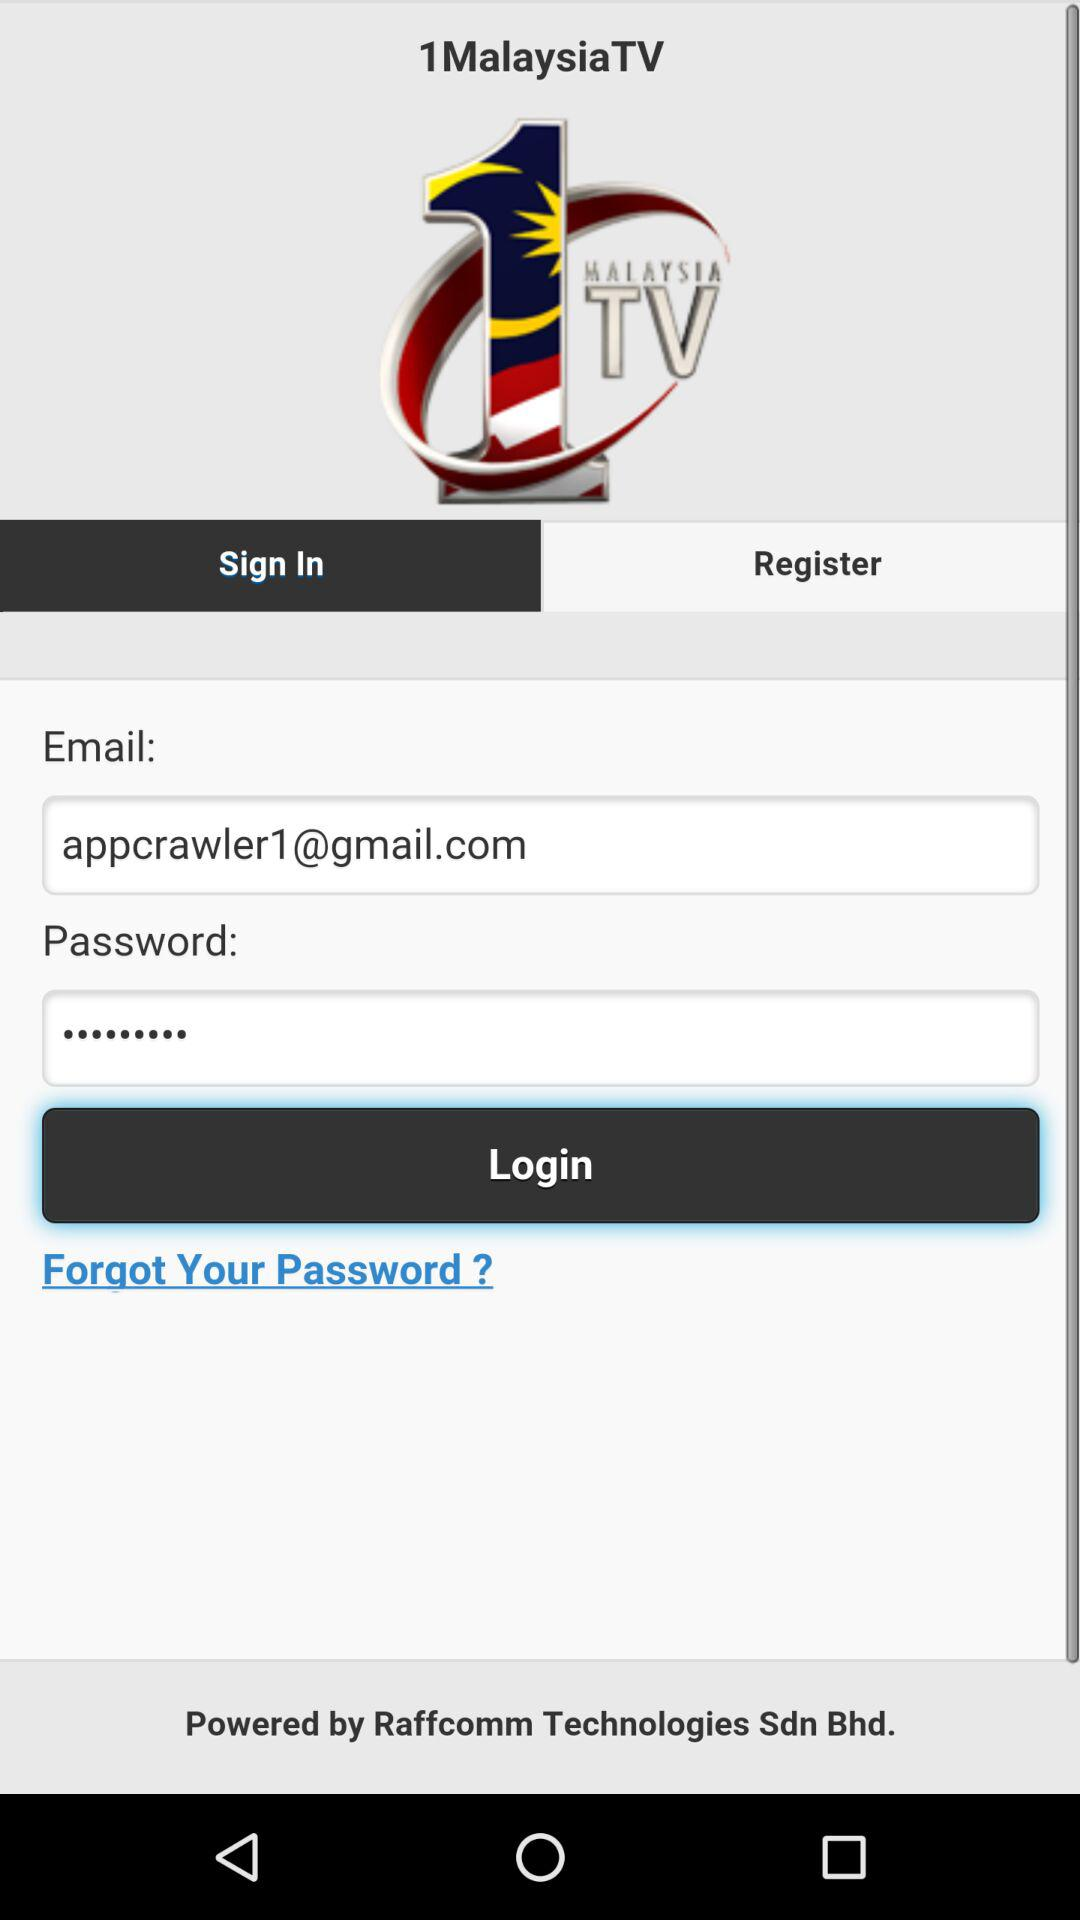What is the email address? The email address is appcrawler1@gmail.com. 